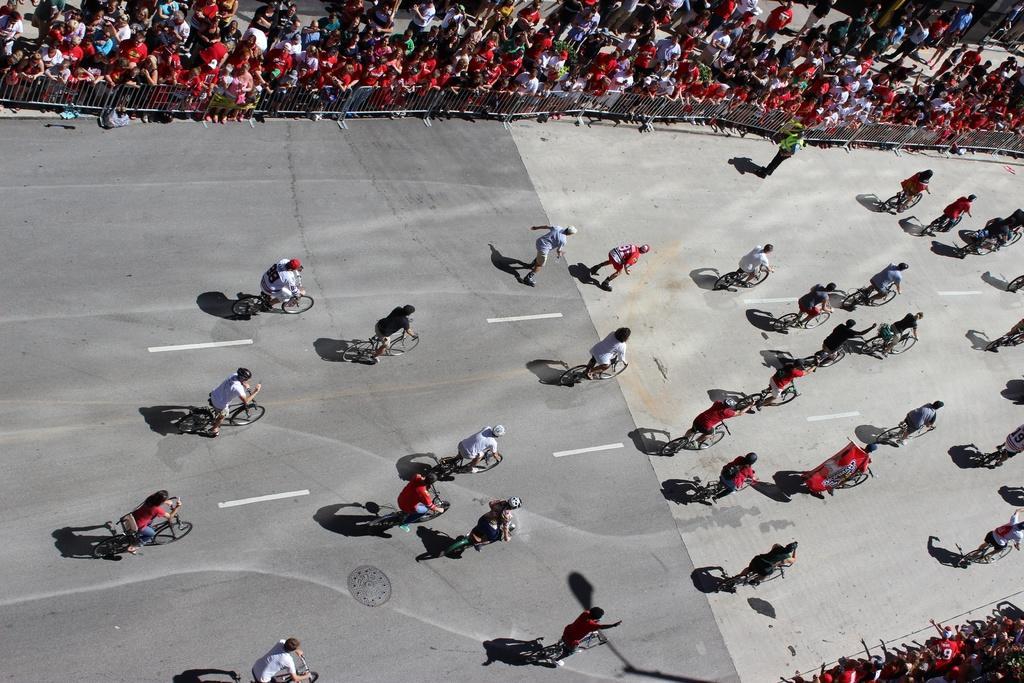Can you describe this image briefly? In this image in the center there are some people, who are sitting on cycle and riding. And at the top of the image and bottom there are some people standing and there is a railing, and at the bottom there is road and one person is running in the center. 